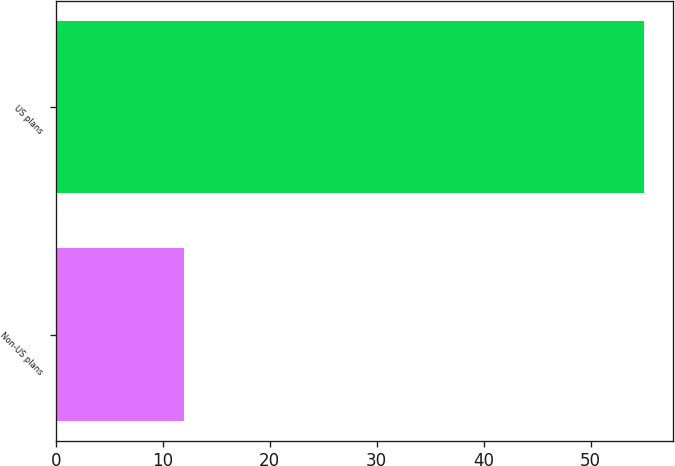Convert chart to OTSL. <chart><loc_0><loc_0><loc_500><loc_500><bar_chart><fcel>Non-US plans<fcel>US plans<nl><fcel>12<fcel>55<nl></chart> 